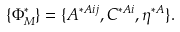Convert formula to latex. <formula><loc_0><loc_0><loc_500><loc_500>\{ \Phi _ { M } ^ { * } \} = \{ A ^ { * A i j } , C ^ { * A i } , \eta ^ { * A } \} .</formula> 